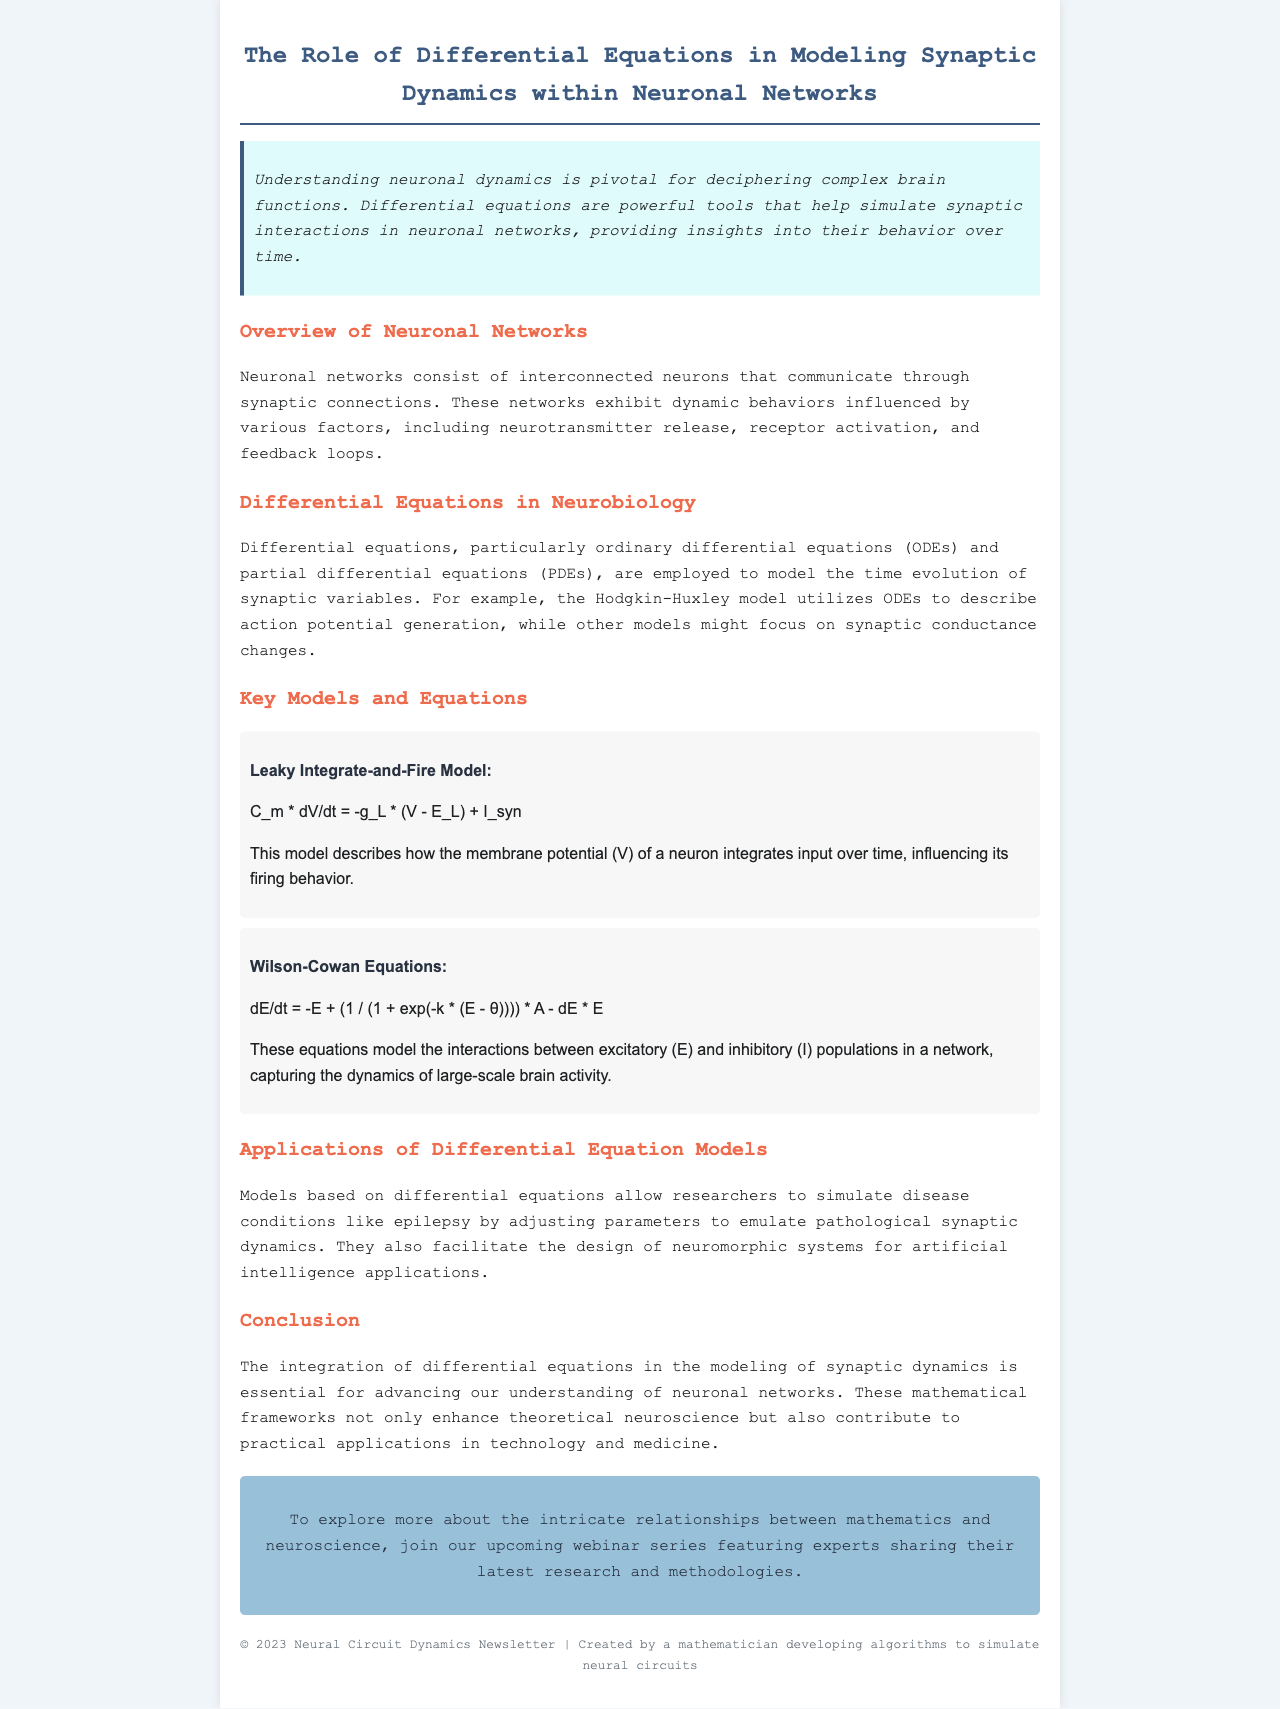What is the title of the newsletter? The title is provided in the header of the document.
Answer: The Role of Differential Equations in Modeling Synaptic Dynamics within Neuronal Networks What model uses ordinary differential equations to describe action potential generation? The document mentions a specific model in the context of differential equations.
Answer: Hodgkin-Huxley model What does the Leaky Integrate-and-Fire Model describe? The document explains the function of this model regarding neuronal behavior.
Answer: Membrane potential integration What do the Wilson-Cowan Equations model? The document discusses the purpose of these equations in the context of neuronal networks.
Answer: Interactions between excitatory and inhibitory populations What is one disease condition simulated by differential equation models? The document lists a specific condition to illustrate the application of the models.
Answer: Epilepsy What type of events will be featured in the upcoming series mentioned in the newsletter? The document suggests the nature of the events in the call to action section.
Answer: Webinars What mathematical framework is emphasized in the conclusion? The conclusion summarizes the type of tools emphasized throughout the document.
Answer: Differential equations 